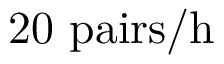Convert formula to latex. <formula><loc_0><loc_0><loc_500><loc_500>2 0 \ p a i r s / h</formula> 